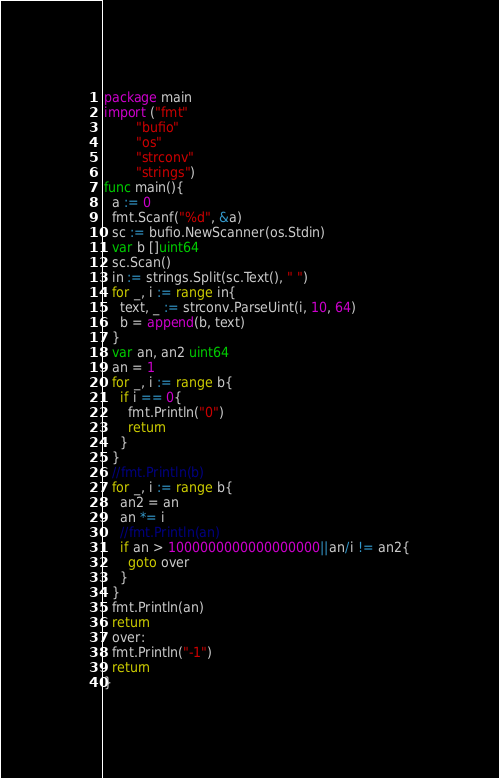<code> <loc_0><loc_0><loc_500><loc_500><_Go_>package main
import ("fmt"
		"bufio"
        "os"
        "strconv"
        "strings")
func main(){
  a := 0
  fmt.Scanf("%d", &a)
  sc := bufio.NewScanner(os.Stdin)
  var b []uint64
  sc.Scan()
  in := strings.Split(sc.Text(), " ")
  for _, i := range in{
    text, _ := strconv.ParseUint(i, 10, 64)
    b = append(b, text)
  }
  var an, an2 uint64
  an = 1
  for _, i := range b{
    if i == 0{
      fmt.Println("0")
      return
    }
  }
  //fmt.Println(b)
  for _, i := range b{
    an2 = an
    an *= i
    //fmt.Println(an)
    if an > 1000000000000000000||an/i != an2{
      goto over
    }
  }
  fmt.Println(an)
  return
  over:
  fmt.Println("-1")
  return
}</code> 